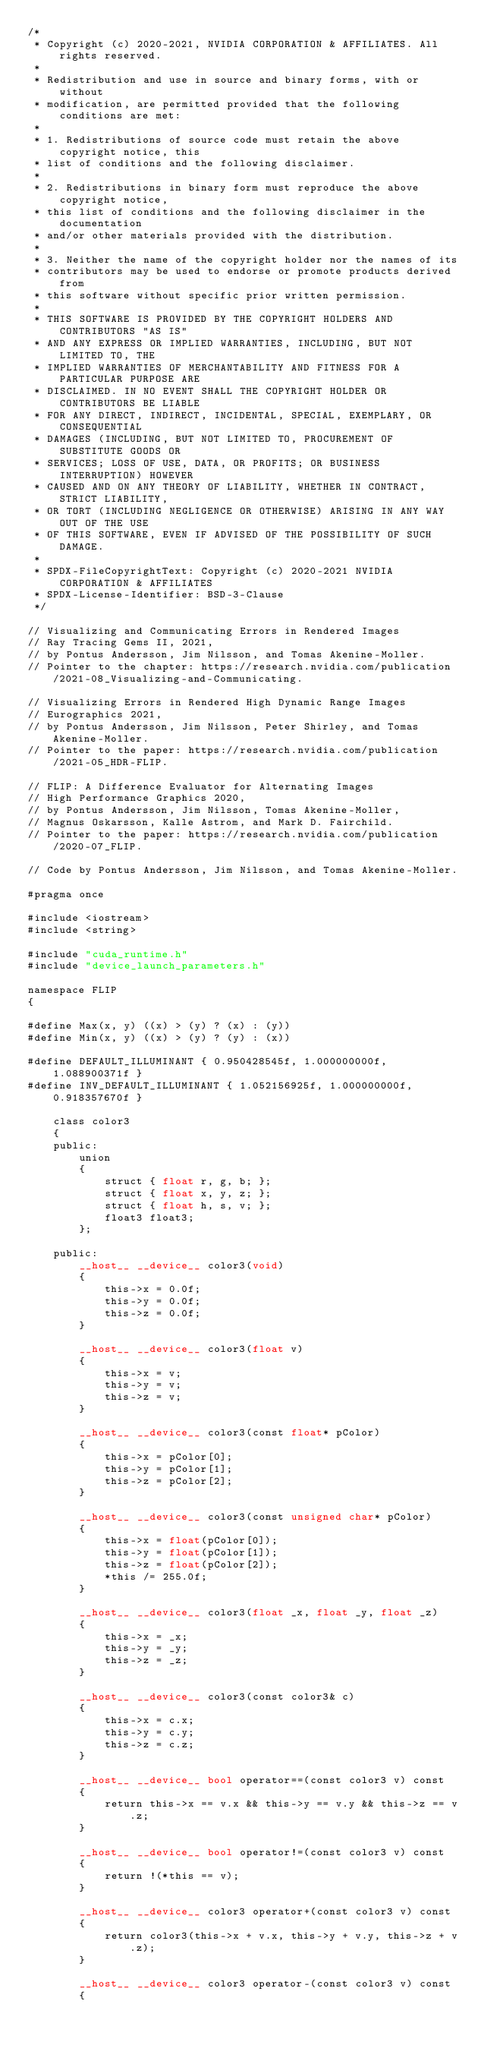Convert code to text. <code><loc_0><loc_0><loc_500><loc_500><_Cuda_>/*
 * Copyright (c) 2020-2021, NVIDIA CORPORATION & AFFILIATES. All rights reserved.
 *
 * Redistribution and use in source and binary forms, with or without
 * modification, are permitted provided that the following conditions are met:
 *
 * 1. Redistributions of source code must retain the above copyright notice, this
 * list of conditions and the following disclaimer.
 *
 * 2. Redistributions in binary form must reproduce the above copyright notice,
 * this list of conditions and the following disclaimer in the documentation
 * and/or other materials provided with the distribution.
 *
 * 3. Neither the name of the copyright holder nor the names of its
 * contributors may be used to endorse or promote products derived from
 * this software without specific prior written permission.
 *
 * THIS SOFTWARE IS PROVIDED BY THE COPYRIGHT HOLDERS AND CONTRIBUTORS "AS IS"
 * AND ANY EXPRESS OR IMPLIED WARRANTIES, INCLUDING, BUT NOT LIMITED TO, THE
 * IMPLIED WARRANTIES OF MERCHANTABILITY AND FITNESS FOR A PARTICULAR PURPOSE ARE
 * DISCLAIMED. IN NO EVENT SHALL THE COPYRIGHT HOLDER OR CONTRIBUTORS BE LIABLE
 * FOR ANY DIRECT, INDIRECT, INCIDENTAL, SPECIAL, EXEMPLARY, OR CONSEQUENTIAL
 * DAMAGES (INCLUDING, BUT NOT LIMITED TO, PROCUREMENT OF SUBSTITUTE GOODS OR
 * SERVICES; LOSS OF USE, DATA, OR PROFITS; OR BUSINESS INTERRUPTION) HOWEVER
 * CAUSED AND ON ANY THEORY OF LIABILITY, WHETHER IN CONTRACT, STRICT LIABILITY,
 * OR TORT (INCLUDING NEGLIGENCE OR OTHERWISE) ARISING IN ANY WAY OUT OF THE USE
 * OF THIS SOFTWARE, EVEN IF ADVISED OF THE POSSIBILITY OF SUCH DAMAGE.
 *
 * SPDX-FileCopyrightText: Copyright (c) 2020-2021 NVIDIA CORPORATION & AFFILIATES
 * SPDX-License-Identifier: BSD-3-Clause
 */

// Visualizing and Communicating Errors in Rendered Images
// Ray Tracing Gems II, 2021,
// by Pontus Andersson, Jim Nilsson, and Tomas Akenine-Moller.
// Pointer to the chapter: https://research.nvidia.com/publication/2021-08_Visualizing-and-Communicating.

// Visualizing Errors in Rendered High Dynamic Range Images
// Eurographics 2021,
// by Pontus Andersson, Jim Nilsson, Peter Shirley, and Tomas Akenine-Moller.
// Pointer to the paper: https://research.nvidia.com/publication/2021-05_HDR-FLIP.

// FLIP: A Difference Evaluator for Alternating Images
// High Performance Graphics 2020,
// by Pontus Andersson, Jim Nilsson, Tomas Akenine-Moller,
// Magnus Oskarsson, Kalle Astrom, and Mark D. Fairchild.
// Pointer to the paper: https://research.nvidia.com/publication/2020-07_FLIP.

// Code by Pontus Andersson, Jim Nilsson, and Tomas Akenine-Moller.

#pragma once

#include <iostream>
#include <string>

#include "cuda_runtime.h"
#include "device_launch_parameters.h"

namespace FLIP
{

#define Max(x, y) ((x) > (y) ? (x) : (y))
#define Min(x, y) ((x) > (y) ? (y) : (x))

#define DEFAULT_ILLUMINANT { 0.950428545f, 1.000000000f, 1.088900371f }
#define INV_DEFAULT_ILLUMINANT { 1.052156925f, 1.000000000f, 0.918357670f }

    class color3
    {
    public:
        union
        {
            struct { float r, g, b; };
            struct { float x, y, z; };
            struct { float h, s, v; };
            float3 float3;
        };

    public:
        __host__ __device__ color3(void)
        {
            this->x = 0.0f;
            this->y = 0.0f;
            this->z = 0.0f;
        }

        __host__ __device__ color3(float v)
        {
            this->x = v;
            this->y = v;
            this->z = v;
        }

        __host__ __device__ color3(const float* pColor)
        {
            this->x = pColor[0];
            this->y = pColor[1];
            this->z = pColor[2];
        }

        __host__ __device__ color3(const unsigned char* pColor)
        {
            this->x = float(pColor[0]);
            this->y = float(pColor[1]);
            this->z = float(pColor[2]);
            *this /= 255.0f;
        }

        __host__ __device__ color3(float _x, float _y, float _z)
        {
            this->x = _x;
            this->y = _y;
            this->z = _z;
        }

        __host__ __device__ color3(const color3& c)
        {
            this->x = c.x;
            this->y = c.y;
            this->z = c.z;
        }

        __host__ __device__ bool operator==(const color3 v) const
        {
            return this->x == v.x && this->y == v.y && this->z == v.z;
        }

        __host__ __device__ bool operator!=(const color3 v) const
        {
            return !(*this == v);
        }

        __host__ __device__ color3 operator+(const color3 v) const
        {
            return color3(this->x + v.x, this->y + v.y, this->z + v.z);
        }

        __host__ __device__ color3 operator-(const color3 v) const
        {</code> 